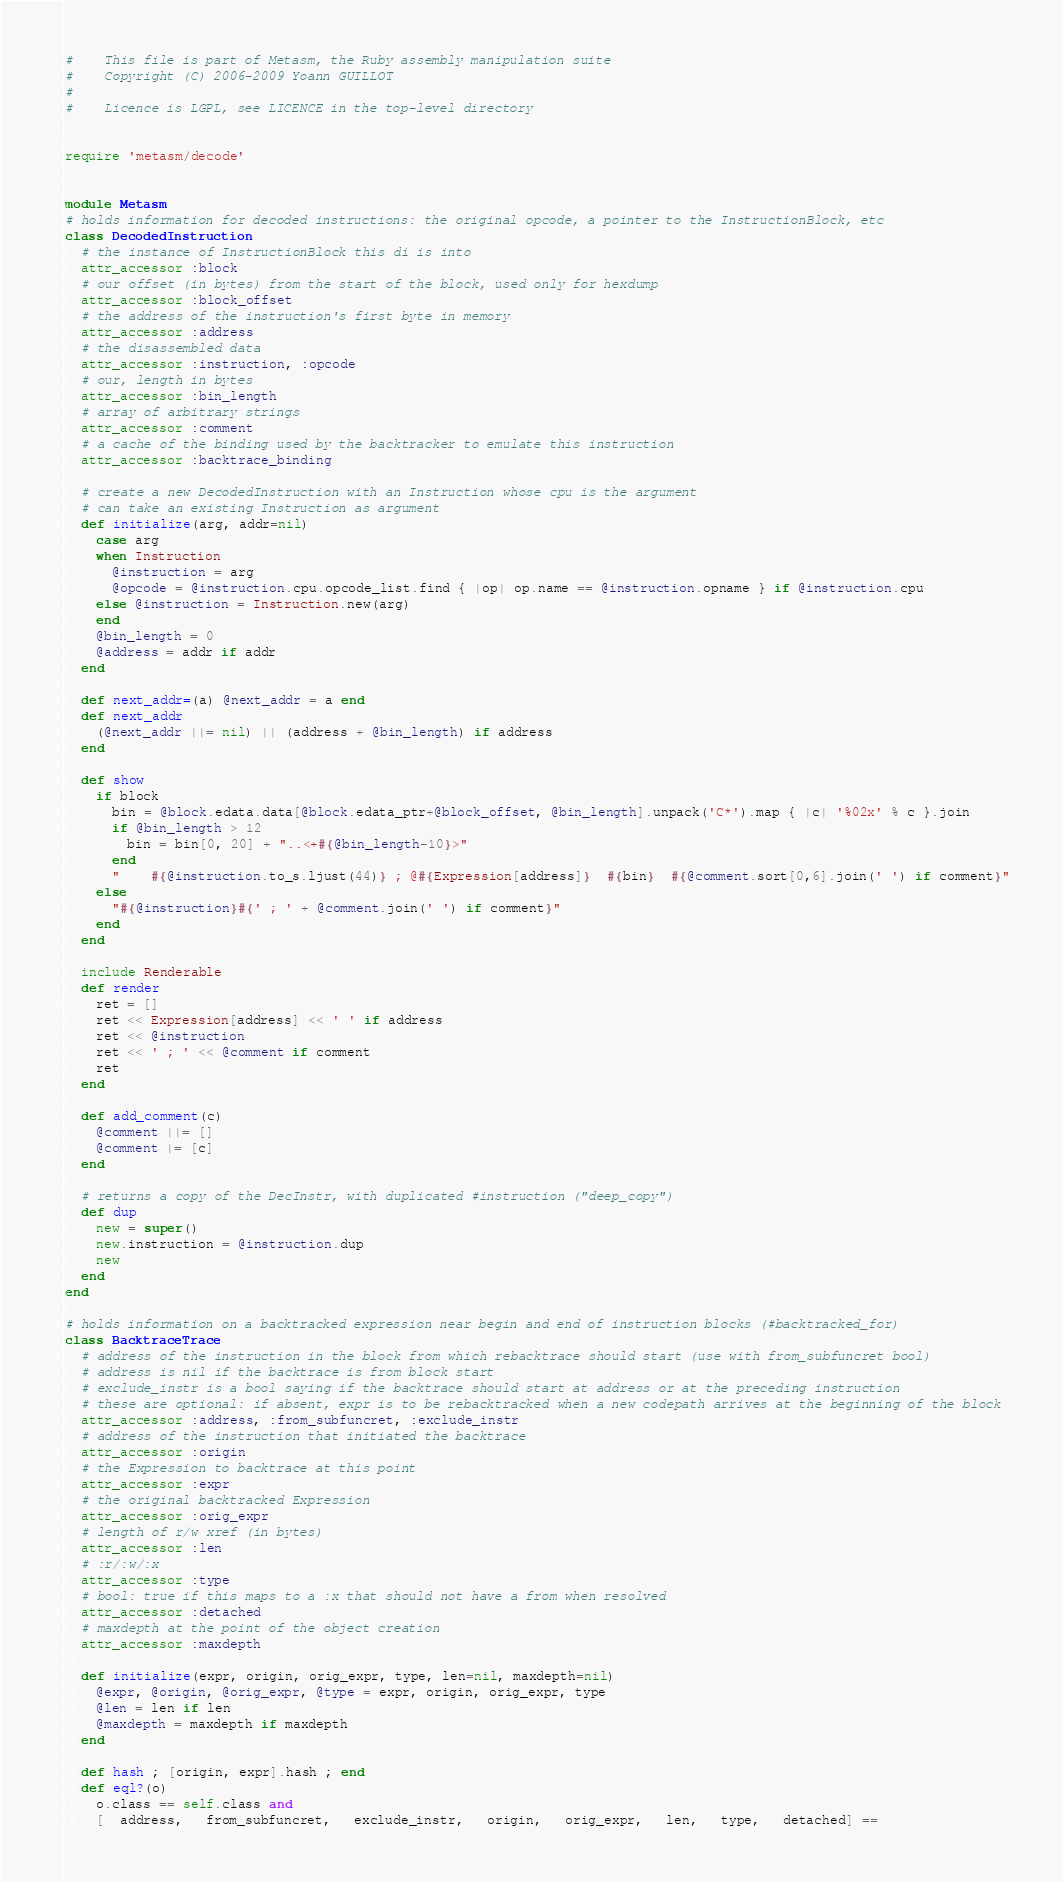Convert code to text. <code><loc_0><loc_0><loc_500><loc_500><_Ruby_>#    This file is part of Metasm, the Ruby assembly manipulation suite
#    Copyright (C) 2006-2009 Yoann GUILLOT
#
#    Licence is LGPL, see LICENCE in the top-level directory


require 'metasm/decode'


module Metasm
# holds information for decoded instructions: the original opcode, a pointer to the InstructionBlock, etc
class DecodedInstruction
  # the instance of InstructionBlock this di is into
  attr_accessor :block
  # our offset (in bytes) from the start of the block, used only for hexdump
  attr_accessor :block_offset
  # the address of the instruction's first byte in memory
  attr_accessor :address
  # the disassembled data
  attr_accessor :instruction, :opcode
  # our, length in bytes
  attr_accessor :bin_length
  # array of arbitrary strings
  attr_accessor :comment
  # a cache of the binding used by the backtracker to emulate this instruction
  attr_accessor :backtrace_binding

  # create a new DecodedInstruction with an Instruction whose cpu is the argument
  # can take an existing Instruction as argument
  def initialize(arg, addr=nil)
    case arg
    when Instruction
      @instruction = arg
      @opcode = @instruction.cpu.opcode_list.find { |op| op.name == @instruction.opname } if @instruction.cpu
    else @instruction = Instruction.new(arg)
    end
    @bin_length = 0
    @address = addr if addr
  end

  def next_addr=(a) @next_addr = a end
  def next_addr
    (@next_addr ||= nil) || (address + @bin_length) if address
  end

  def show
    if block
      bin = @block.edata.data[@block.edata_ptr+@block_offset, @bin_length].unpack('C*').map { |c| '%02x' % c }.join
      if @bin_length > 12
        bin = bin[0, 20] + "..<+#{@bin_length-10}>"
      end
      "    #{@instruction.to_s.ljust(44)} ; @#{Expression[address]}  #{bin}  #{@comment.sort[0,6].join(' ') if comment}"
    else
      "#{@instruction}#{' ; ' + @comment.join(' ') if comment}"
    end
  end

  include Renderable
  def render
    ret = []
    ret << Expression[address] << ' ' if address
    ret << @instruction
    ret << ' ; ' << @comment if comment
    ret
  end

  def add_comment(c)
    @comment ||= []
    @comment |= [c]
  end

  # returns a copy of the DecInstr, with duplicated #instruction ("deep_copy")
  def dup
    new = super()
    new.instruction = @instruction.dup
    new
  end
end

# holds information on a backtracked expression near begin and end of instruction blocks (#backtracked_for)
class BacktraceTrace
  # address of the instruction in the block from which rebacktrace should start (use with from_subfuncret bool)
  # address is nil if the backtrace is from block start
  # exclude_instr is a bool saying if the backtrace should start at address or at the preceding instruction
  # these are optional: if absent, expr is to be rebacktracked when a new codepath arrives at the beginning of the block
  attr_accessor :address, :from_subfuncret, :exclude_instr
  # address of the instruction that initiated the backtrace
  attr_accessor :origin
  # the Expression to backtrace at this point
  attr_accessor :expr
  # the original backtracked Expression
  attr_accessor :orig_expr
  # length of r/w xref (in bytes)
  attr_accessor :len
  # :r/:w/:x
  attr_accessor :type
  # bool: true if this maps to a :x that should not have a from when resolved
  attr_accessor :detached
  # maxdepth at the point of the object creation
  attr_accessor :maxdepth

  def initialize(expr, origin, orig_expr, type, len=nil, maxdepth=nil)
    @expr, @origin, @orig_expr, @type = expr, origin, orig_expr, type
    @len = len if len
    @maxdepth = maxdepth if maxdepth
  end

  def hash ; [origin, expr].hash ; end
  def eql?(o)
    o.class == self.class and
    [  address,   from_subfuncret,   exclude_instr,   origin,   orig_expr,   len,   type,   detached] ==</code> 